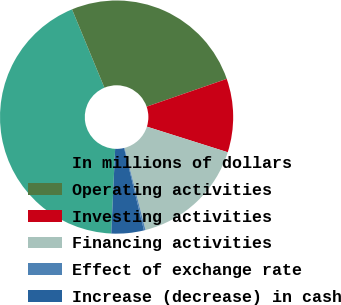<chart> <loc_0><loc_0><loc_500><loc_500><pie_chart><fcel>In millions of dollars<fcel>Operating activities<fcel>Investing activities<fcel>Financing activities<fcel>Effect of exchange rate<fcel>Increase (decrease) in cash<nl><fcel>43.03%<fcel>25.93%<fcel>10.19%<fcel>16.13%<fcel>0.22%<fcel>4.5%<nl></chart> 